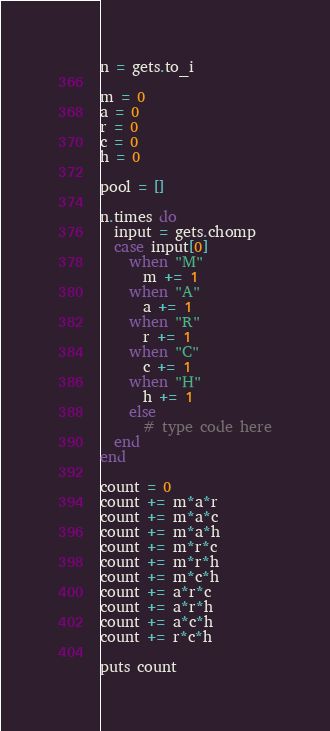<code> <loc_0><loc_0><loc_500><loc_500><_Ruby_>n = gets.to_i

m = 0
a = 0
r = 0
c = 0
h = 0

pool = []

n.times do
  input = gets.chomp
  case input[0]
    when "M"
      m += 1
    when "A"
      a += 1
    when "R"
      r += 1
    when "C"
      c += 1
    when "H"
      h += 1
    else
      # type code here
  end
end

count = 0
count += m*a*r
count += m*a*c
count += m*a*h
count += m*r*c
count += m*r*h
count += m*c*h
count += a*r*c
count += a*r*h
count += a*c*h
count += r*c*h

puts count</code> 